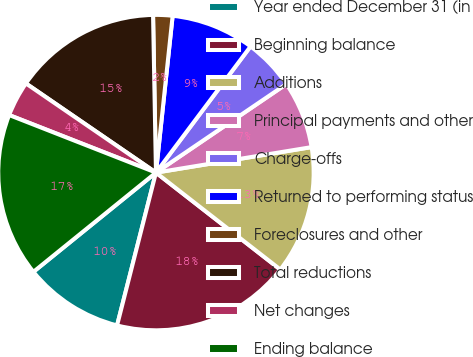Convert chart to OTSL. <chart><loc_0><loc_0><loc_500><loc_500><pie_chart><fcel>Year ended December 31 (in<fcel>Beginning balance<fcel>Additions<fcel>Principal payments and other<fcel>Charge-offs<fcel>Returned to performing status<fcel>Foreclosures and other<fcel>Total reductions<fcel>Net changes<fcel>Ending balance<nl><fcel>10.2%<fcel>18.43%<fcel>13.12%<fcel>6.91%<fcel>5.27%<fcel>8.55%<fcel>1.98%<fcel>15.14%<fcel>3.62%<fcel>16.78%<nl></chart> 